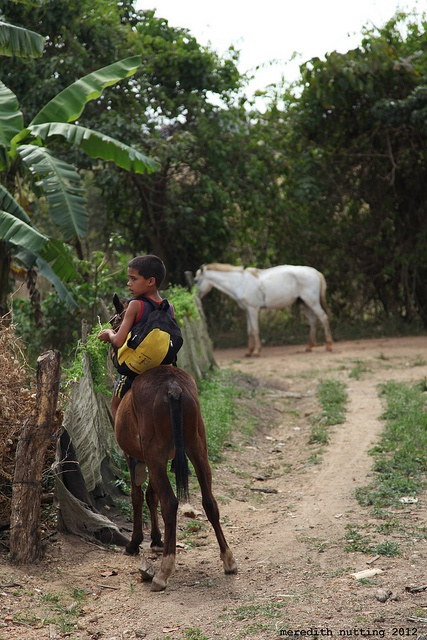Describe the objects in this image and their specific colors. I can see horse in black, maroon, and gray tones, people in black, maroon, and olive tones, horse in black, darkgray, lightgray, and gray tones, and backpack in black and olive tones in this image. 